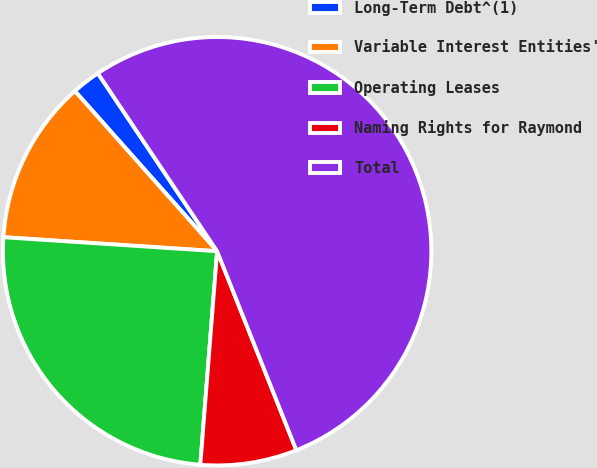Convert chart to OTSL. <chart><loc_0><loc_0><loc_500><loc_500><pie_chart><fcel>Long-Term Debt^(1)<fcel>Variable Interest Entities'<fcel>Operating Leases<fcel>Naming Rights for Raymond<fcel>Total<nl><fcel>2.16%<fcel>12.4%<fcel>24.79%<fcel>7.28%<fcel>53.37%<nl></chart> 